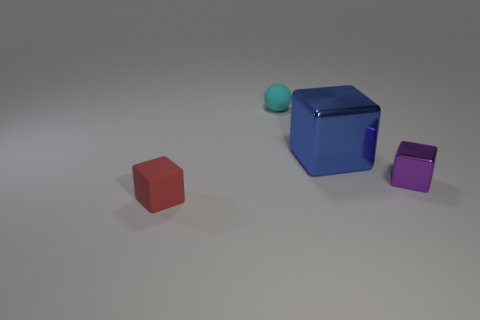Are there more tiny purple metallic things than green rubber things?
Provide a short and direct response. Yes. What is the size of the blue metallic thing that is the same shape as the purple shiny object?
Offer a terse response. Large. Do the cyan thing and the block to the left of the big blue shiny cube have the same material?
Give a very brief answer. Yes. How many things are blue metallic objects or tiny red rubber cubes?
Keep it short and to the point. 2. Do the cube that is to the left of the cyan matte ball and the rubber thing behind the purple object have the same size?
Give a very brief answer. Yes. How many cubes are either purple shiny objects or small red rubber objects?
Offer a terse response. 2. Is there a big shiny sphere?
Keep it short and to the point. No. Is there any other thing that is the same shape as the cyan rubber object?
Ensure brevity in your answer.  No. How many objects are things behind the small red block or big green metal cubes?
Provide a succinct answer. 3. How many rubber objects are behind the cyan rubber ball behind the tiny cube on the right side of the tiny cyan matte sphere?
Ensure brevity in your answer.  0. 